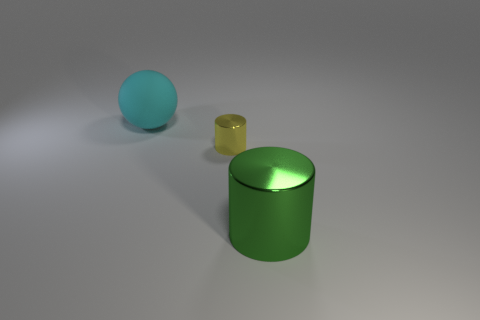Add 3 large purple shiny things. How many objects exist? 6 Subtract all spheres. How many objects are left? 2 Subtract 0 blue balls. How many objects are left? 3 Subtract all cyan objects. Subtract all large green blocks. How many objects are left? 2 Add 1 large green cylinders. How many large green cylinders are left? 2 Add 2 small purple cubes. How many small purple cubes exist? 2 